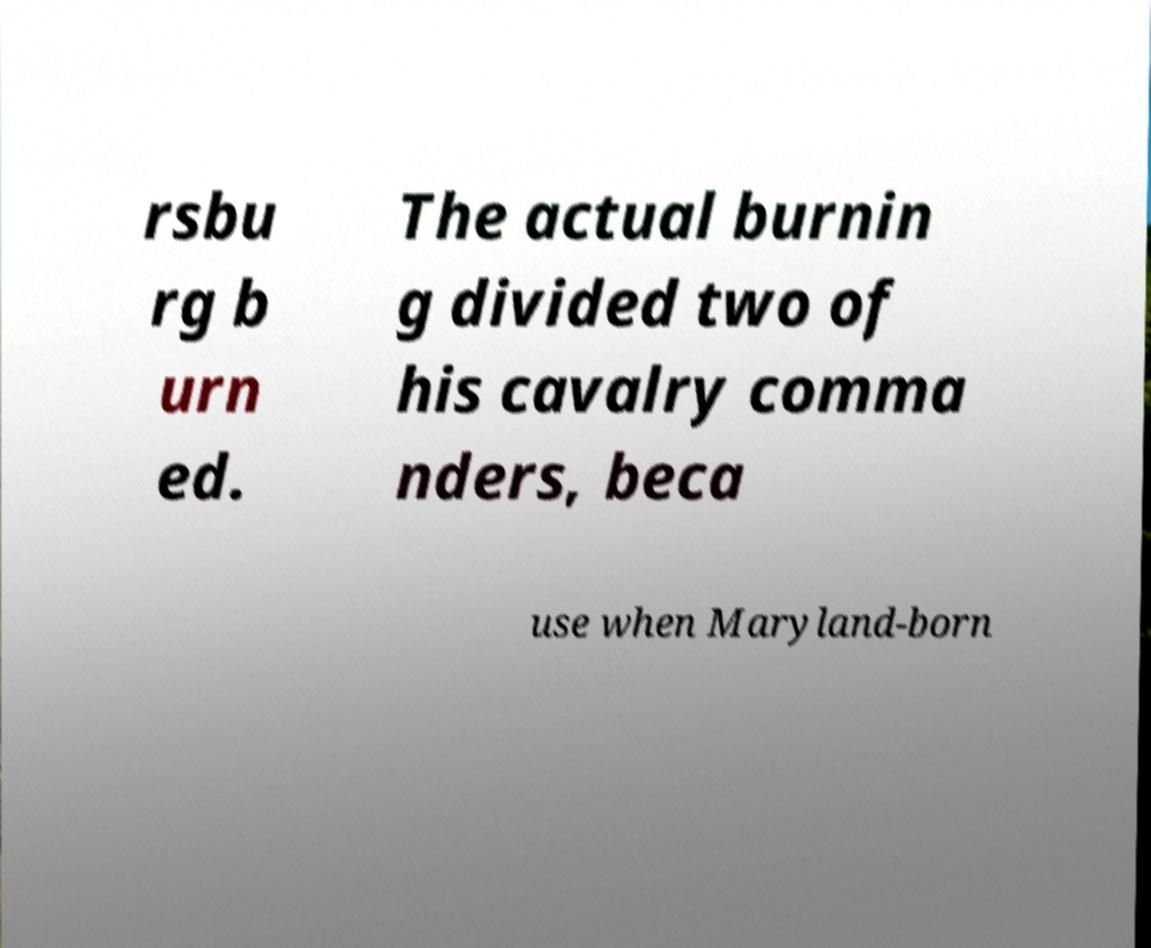Could you assist in decoding the text presented in this image and type it out clearly? rsbu rg b urn ed. The actual burnin g divided two of his cavalry comma nders, beca use when Maryland-born 